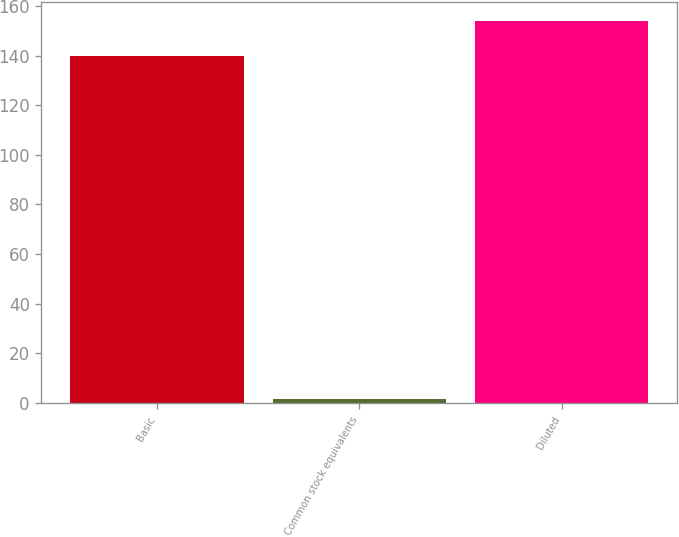<chart> <loc_0><loc_0><loc_500><loc_500><bar_chart><fcel>Basic<fcel>Common stock equivalents<fcel>Diluted<nl><fcel>140<fcel>1.6<fcel>154<nl></chart> 